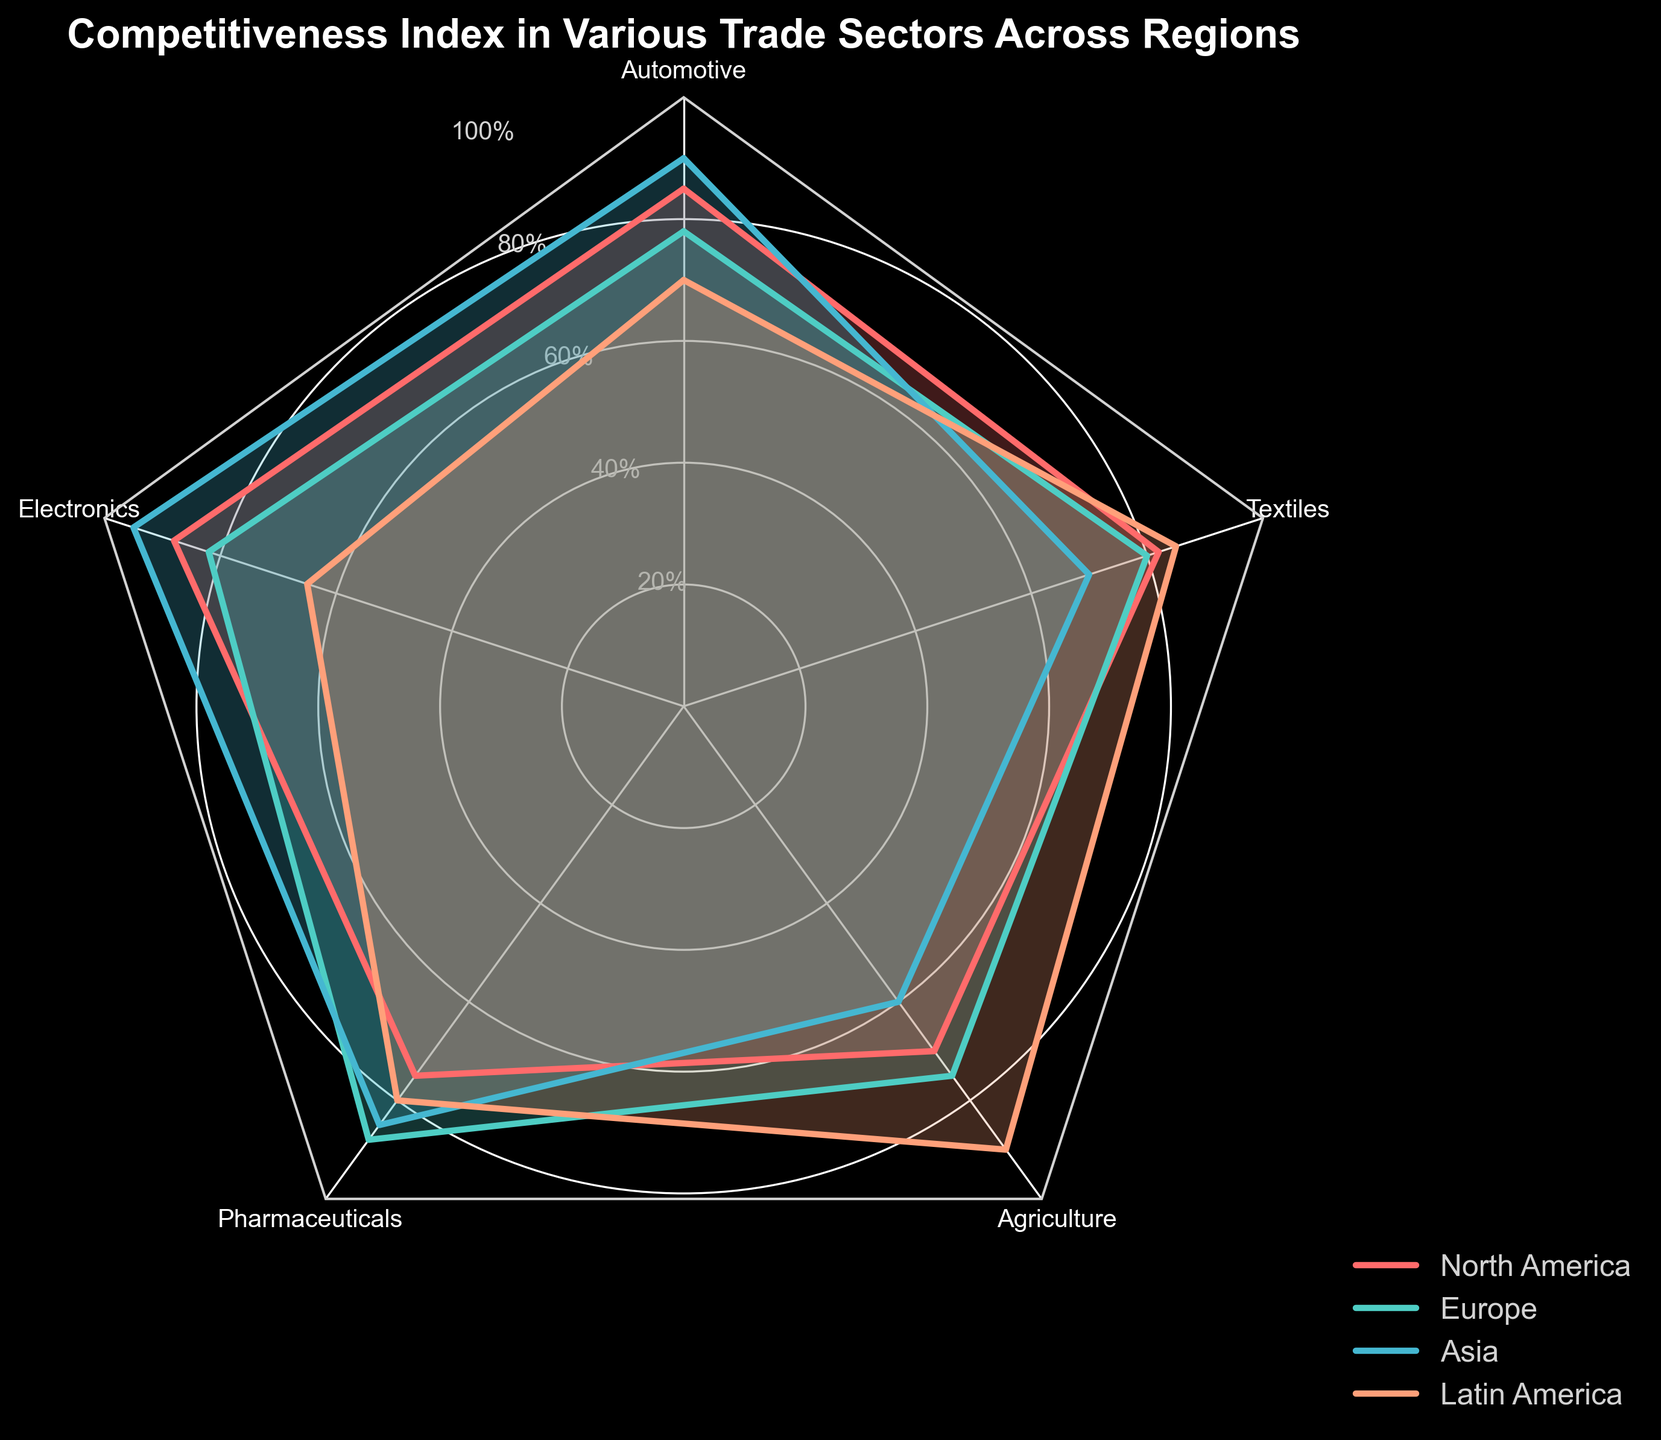What's the title of the plot? The title of the plot is usually found at the top of the figure and provides information about what the chart represents.
Answer: Competitiveness Index in Various Trade Sectors Across Regions What are the sectors shown in the radar chart? The sectors are the different trade sectors listed on the edges of the radar chart. They are usually labeled in correspondence with the axes of the chart.
Answer: Automotive, Electronics, Pharmaceuticals, Agriculture, Textiles Which region has the highest competitiveness index in the Electronics sector? We need to look at the values plotted for the Electronics sector and identify the highest point among the regions. Asia is shown having the highest value.
Answer: Asia Which sector has the lowest competitiveness index in North America? By examining the plotted points for North America across all sectors, the sector with the lowest value will be identified; it's the sector with the smallest distance from the center along North America's plot line.
Answer: Agriculture What's the average competitiveness index for Pharmaceuticals across all regions? Sum the values for Pharmaceuticals in all regions and then divide by the number of regions. The values are 75 (North America), 88 (Europe), 85 (Asia), 80 (Latin America); the sum is 328, and the average is 328/4.
Answer: 82 Which regions have overlapping competitive indices in Agriculture? Look at the Agriculture sector specifically, and identify which regions’ values are close or coincide visually on the radar chart.
Answer: North America and Europe How does the competitiveness index for Textiles in Latin America compare to North America? Check the values for the Textiles sector for both Latin America and North America and compare them. Latin America has a higher value.
Answer: Latin America > North America Determine the difference in competitiveness index between Europe and Asia for the Automotive sector. Subtract Europe’s value from Asia’s value for the Automotive sector. The values are 90 (Asia) and 78 (Europe); thus, the difference is 90 - 78.
Answer: 12 Is the competitiveness index for Agriculture in Latin America greater than in Europe? Compare the values for the Agriculture sector in Latin America and Europe. Latin America's value is higher.
Answer: Yes In which sector is the competitiveness index the most similar across all regions? Identify the sector where the plotted values for all regions are closest to each other visually.
Answer: Pharmaceuticals 